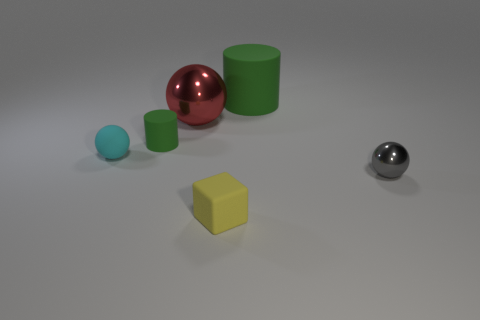Add 1 green rubber objects. How many objects exist? 7 Subtract all cubes. How many objects are left? 5 Add 3 small green cylinders. How many small green cylinders exist? 4 Subtract 1 yellow blocks. How many objects are left? 5 Subtract all spheres. Subtract all small matte things. How many objects are left? 0 Add 2 metal things. How many metal things are left? 4 